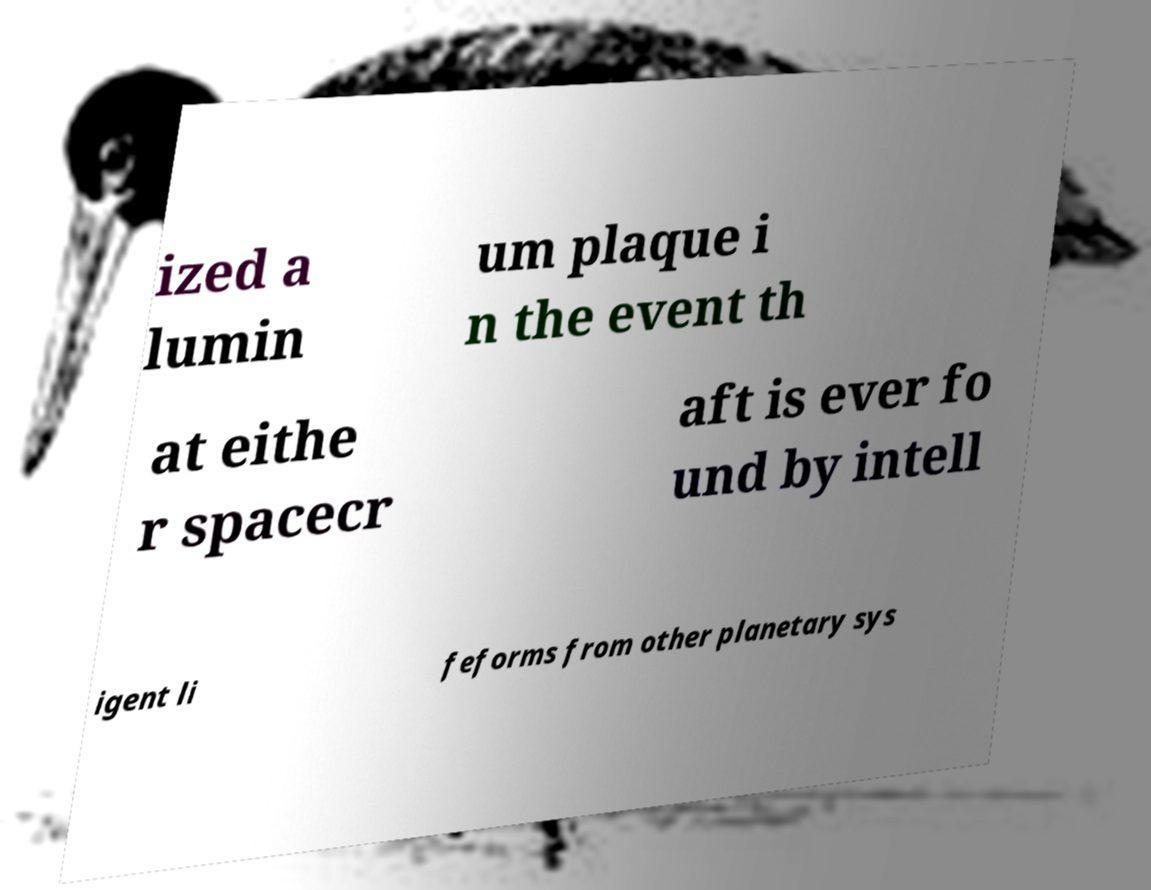Could you assist in decoding the text presented in this image and type it out clearly? ized a lumin um plaque i n the event th at eithe r spacecr aft is ever fo und by intell igent li feforms from other planetary sys 